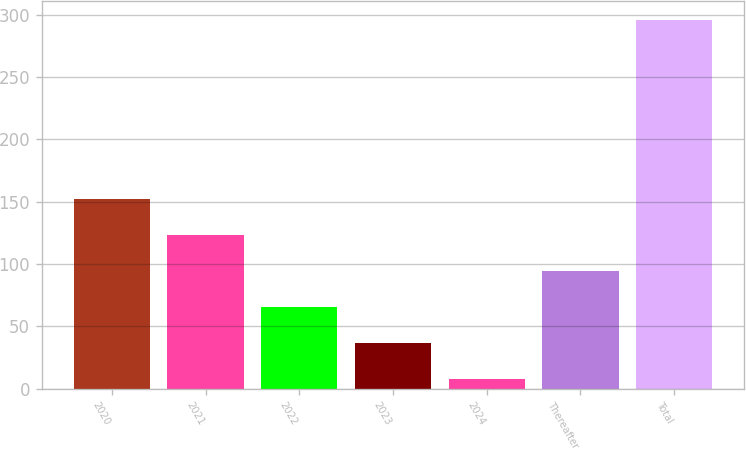Convert chart to OTSL. <chart><loc_0><loc_0><loc_500><loc_500><bar_chart><fcel>2020<fcel>2021<fcel>2022<fcel>2023<fcel>2024<fcel>Thereafter<fcel>Total<nl><fcel>152<fcel>123.2<fcel>65.6<fcel>36.8<fcel>8<fcel>94.4<fcel>296<nl></chart> 